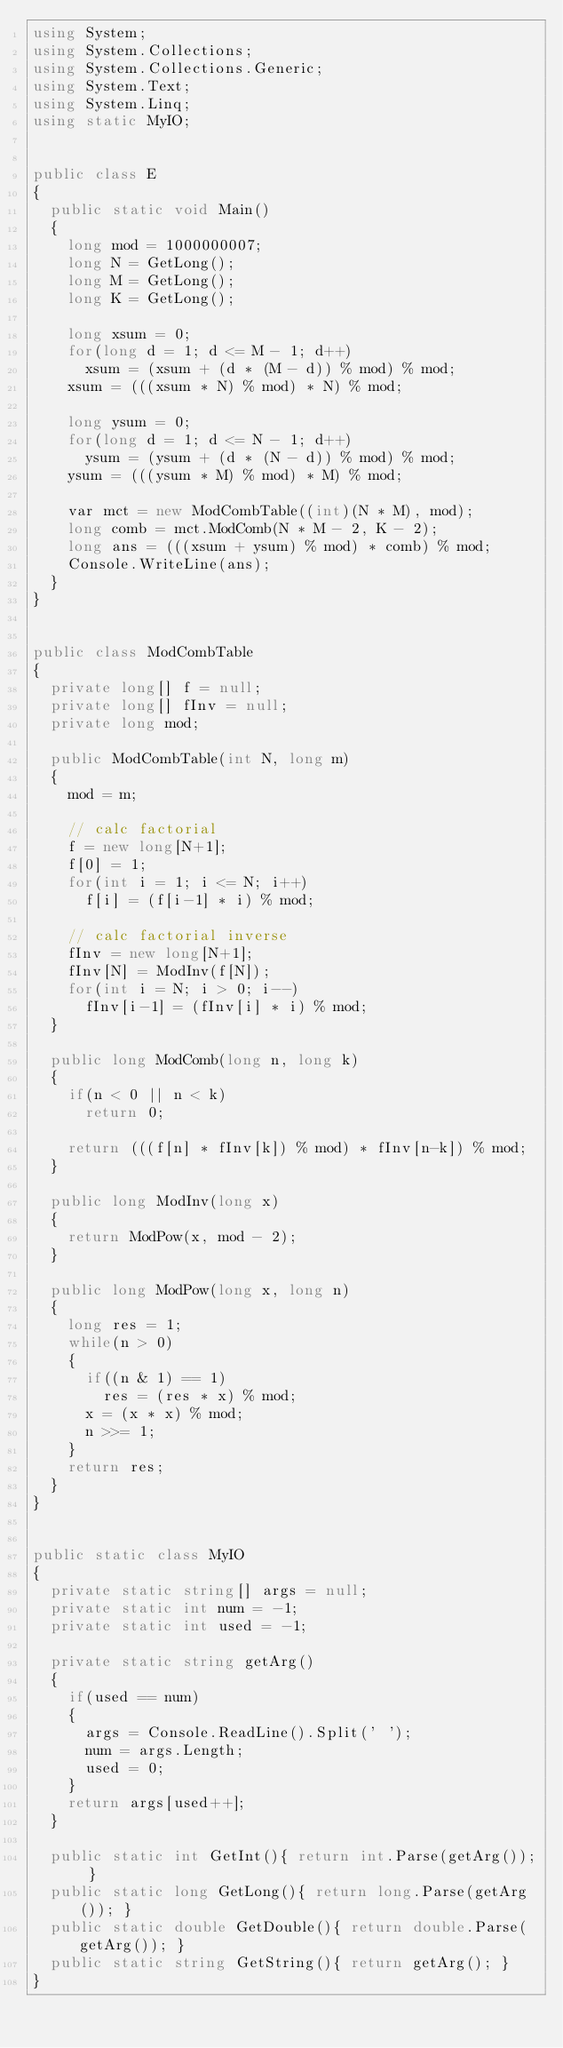Convert code to text. <code><loc_0><loc_0><loc_500><loc_500><_C#_>using System;
using System.Collections;
using System.Collections.Generic;
using System.Text;
using System.Linq;
using static MyIO;


public class E
{
	public static void Main()
	{
		long mod = 1000000007;
		long N = GetLong();
		long M = GetLong();
		long K = GetLong();

		long xsum = 0;
		for(long d = 1; d <= M - 1; d++)
			xsum = (xsum + (d * (M - d)) % mod) % mod;
		xsum = (((xsum * N) % mod) * N) % mod;

		long ysum = 0;
		for(long d = 1; d <= N - 1; d++)
			ysum = (ysum + (d * (N - d)) % mod) % mod;
		ysum = (((ysum * M) % mod) * M) % mod;
		
		var mct = new ModCombTable((int)(N * M), mod);
		long comb = mct.ModComb(N * M - 2, K - 2);
		long ans = (((xsum + ysum) % mod) * comb) % mod;
		Console.WriteLine(ans);
	}
}


public class ModCombTable
{
	private long[] f = null;
	private long[] fInv = null;
	private long mod;

	public ModCombTable(int N, long m)
	{
		mod = m;

		// calc factorial
		f = new long[N+1];
		f[0] = 1;
		for(int i = 1; i <= N; i++)
			f[i] = (f[i-1] * i) % mod;

		// calc factorial inverse
		fInv = new long[N+1];
		fInv[N] = ModInv(f[N]);
		for(int i = N; i > 0; i--)
			fInv[i-1] = (fInv[i] * i) % mod;
	}

	public long ModComb(long n, long k)
	{
		if(n < 0 || n < k)
			return 0;
		
		return (((f[n] * fInv[k]) % mod) * fInv[n-k]) % mod;
	}

	public long ModInv(long x)
	{
		return ModPow(x, mod - 2);
	}

	public long ModPow(long x, long n)
	{
		long res = 1;
		while(n > 0)
		{
			if((n & 1) == 1)
				res = (res * x) % mod;
			x = (x * x) % mod;
			n >>= 1;
		}
		return res;
	}
}


public static class MyIO
{
	private static string[] args = null;
	private static int num = -1;
	private static int used = -1;

	private static string getArg()
	{
		if(used == num)
		{
			args = Console.ReadLine().Split(' ');
			num = args.Length;
			used = 0;
		}
		return args[used++];
	}

	public static int GetInt(){ return int.Parse(getArg()); }
	public static long GetLong(){ return long.Parse(getArg()); }
	public static double GetDouble(){ return double.Parse(getArg()); }
	public static string GetString(){ return getArg(); }
}



</code> 